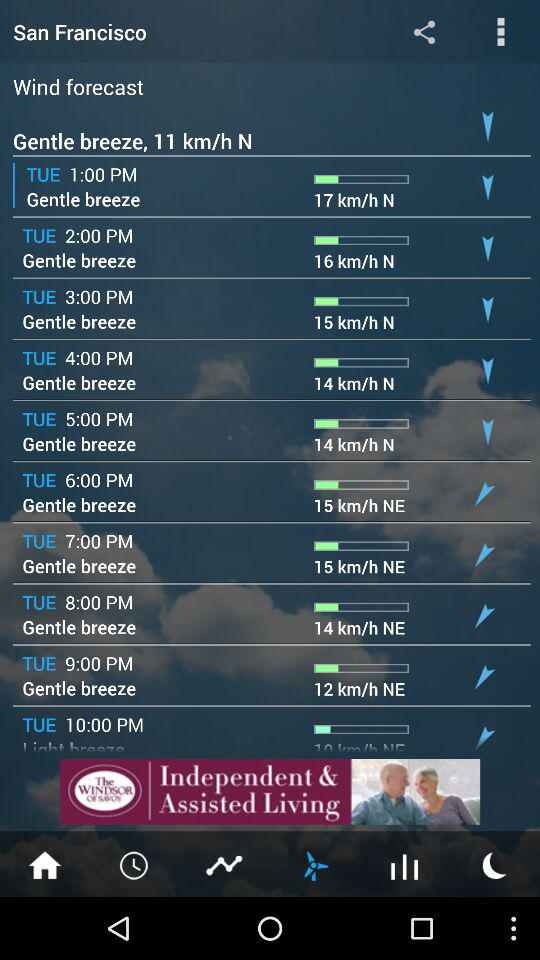At what time was the speed of the breeze 12 kilometers per hour? The speed of the breeze was 12 kilometers per hour at 9:00 PM. 